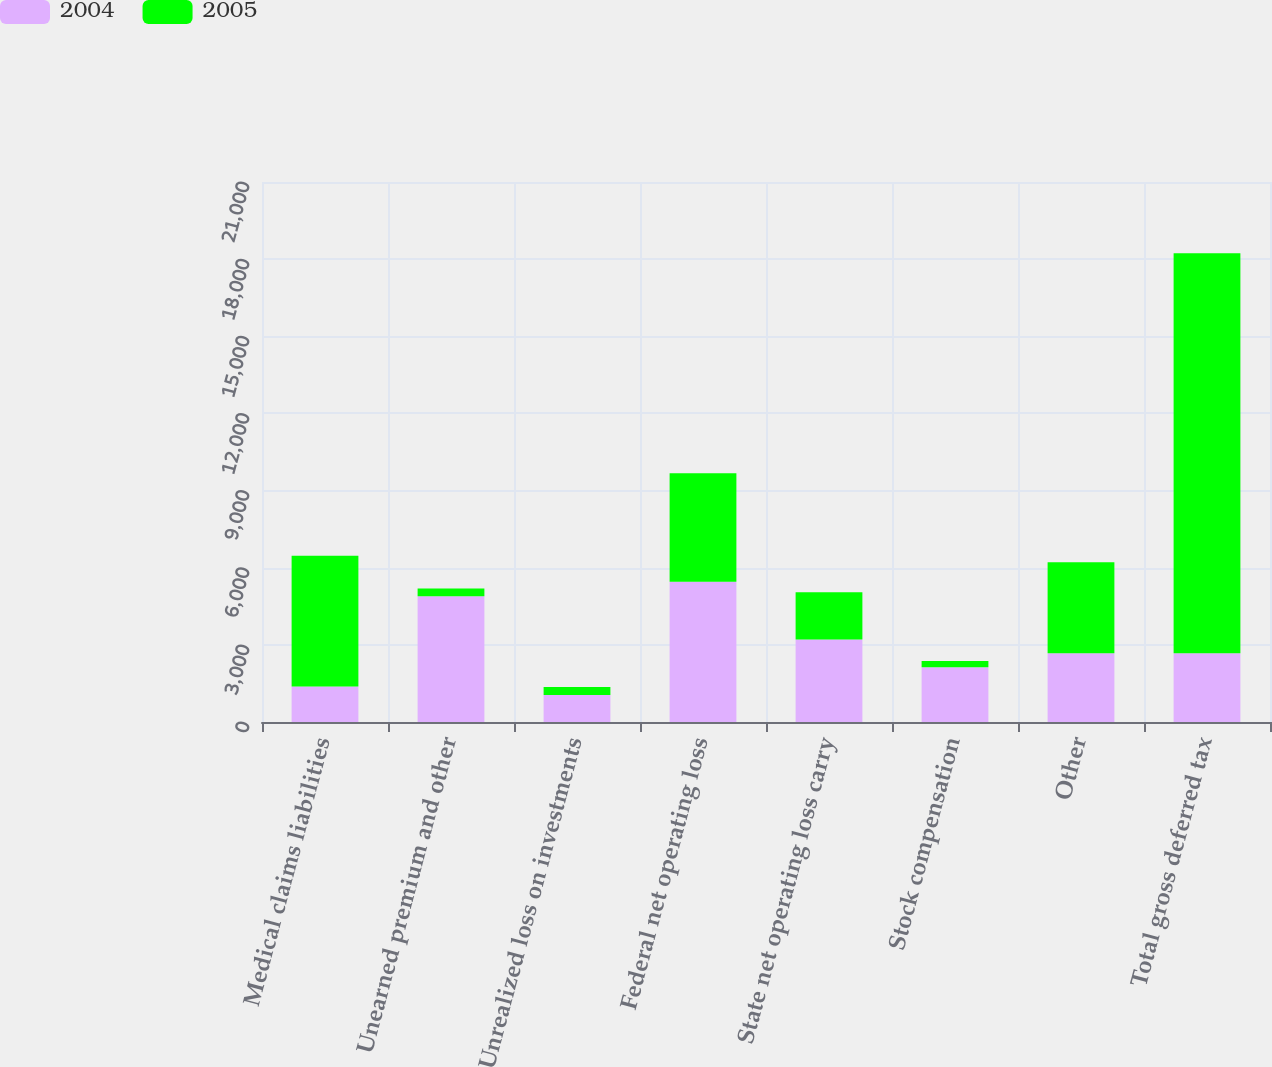Convert chart. <chart><loc_0><loc_0><loc_500><loc_500><stacked_bar_chart><ecel><fcel>Medical claims liabilities<fcel>Unearned premium and other<fcel>Unrealized loss on investments<fcel>Federal net operating loss<fcel>State net operating loss carry<fcel>Stock compensation<fcel>Other<fcel>Total gross deferred tax<nl><fcel>2004<fcel>1383<fcel>4890<fcel>1053<fcel>5452<fcel>3205<fcel>2126<fcel>2675<fcel>2675<nl><fcel>2005<fcel>5086<fcel>304<fcel>312<fcel>4219<fcel>1845<fcel>243<fcel>3542<fcel>15551<nl></chart> 